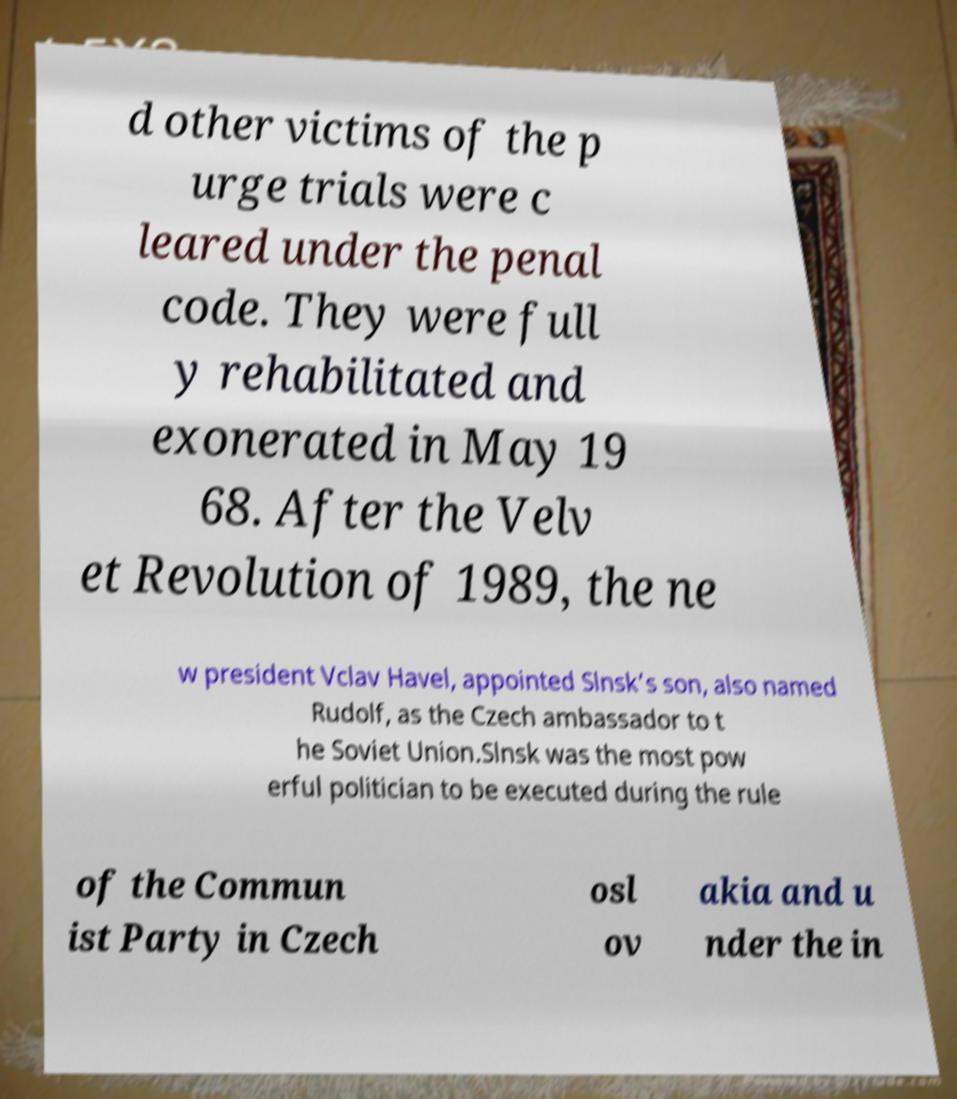Could you assist in decoding the text presented in this image and type it out clearly? d other victims of the p urge trials were c leared under the penal code. They were full y rehabilitated and exonerated in May 19 68. After the Velv et Revolution of 1989, the ne w president Vclav Havel, appointed Slnsk’s son, also named Rudolf, as the Czech ambassador to t he Soviet Union.Slnsk was the most pow erful politician to be executed during the rule of the Commun ist Party in Czech osl ov akia and u nder the in 